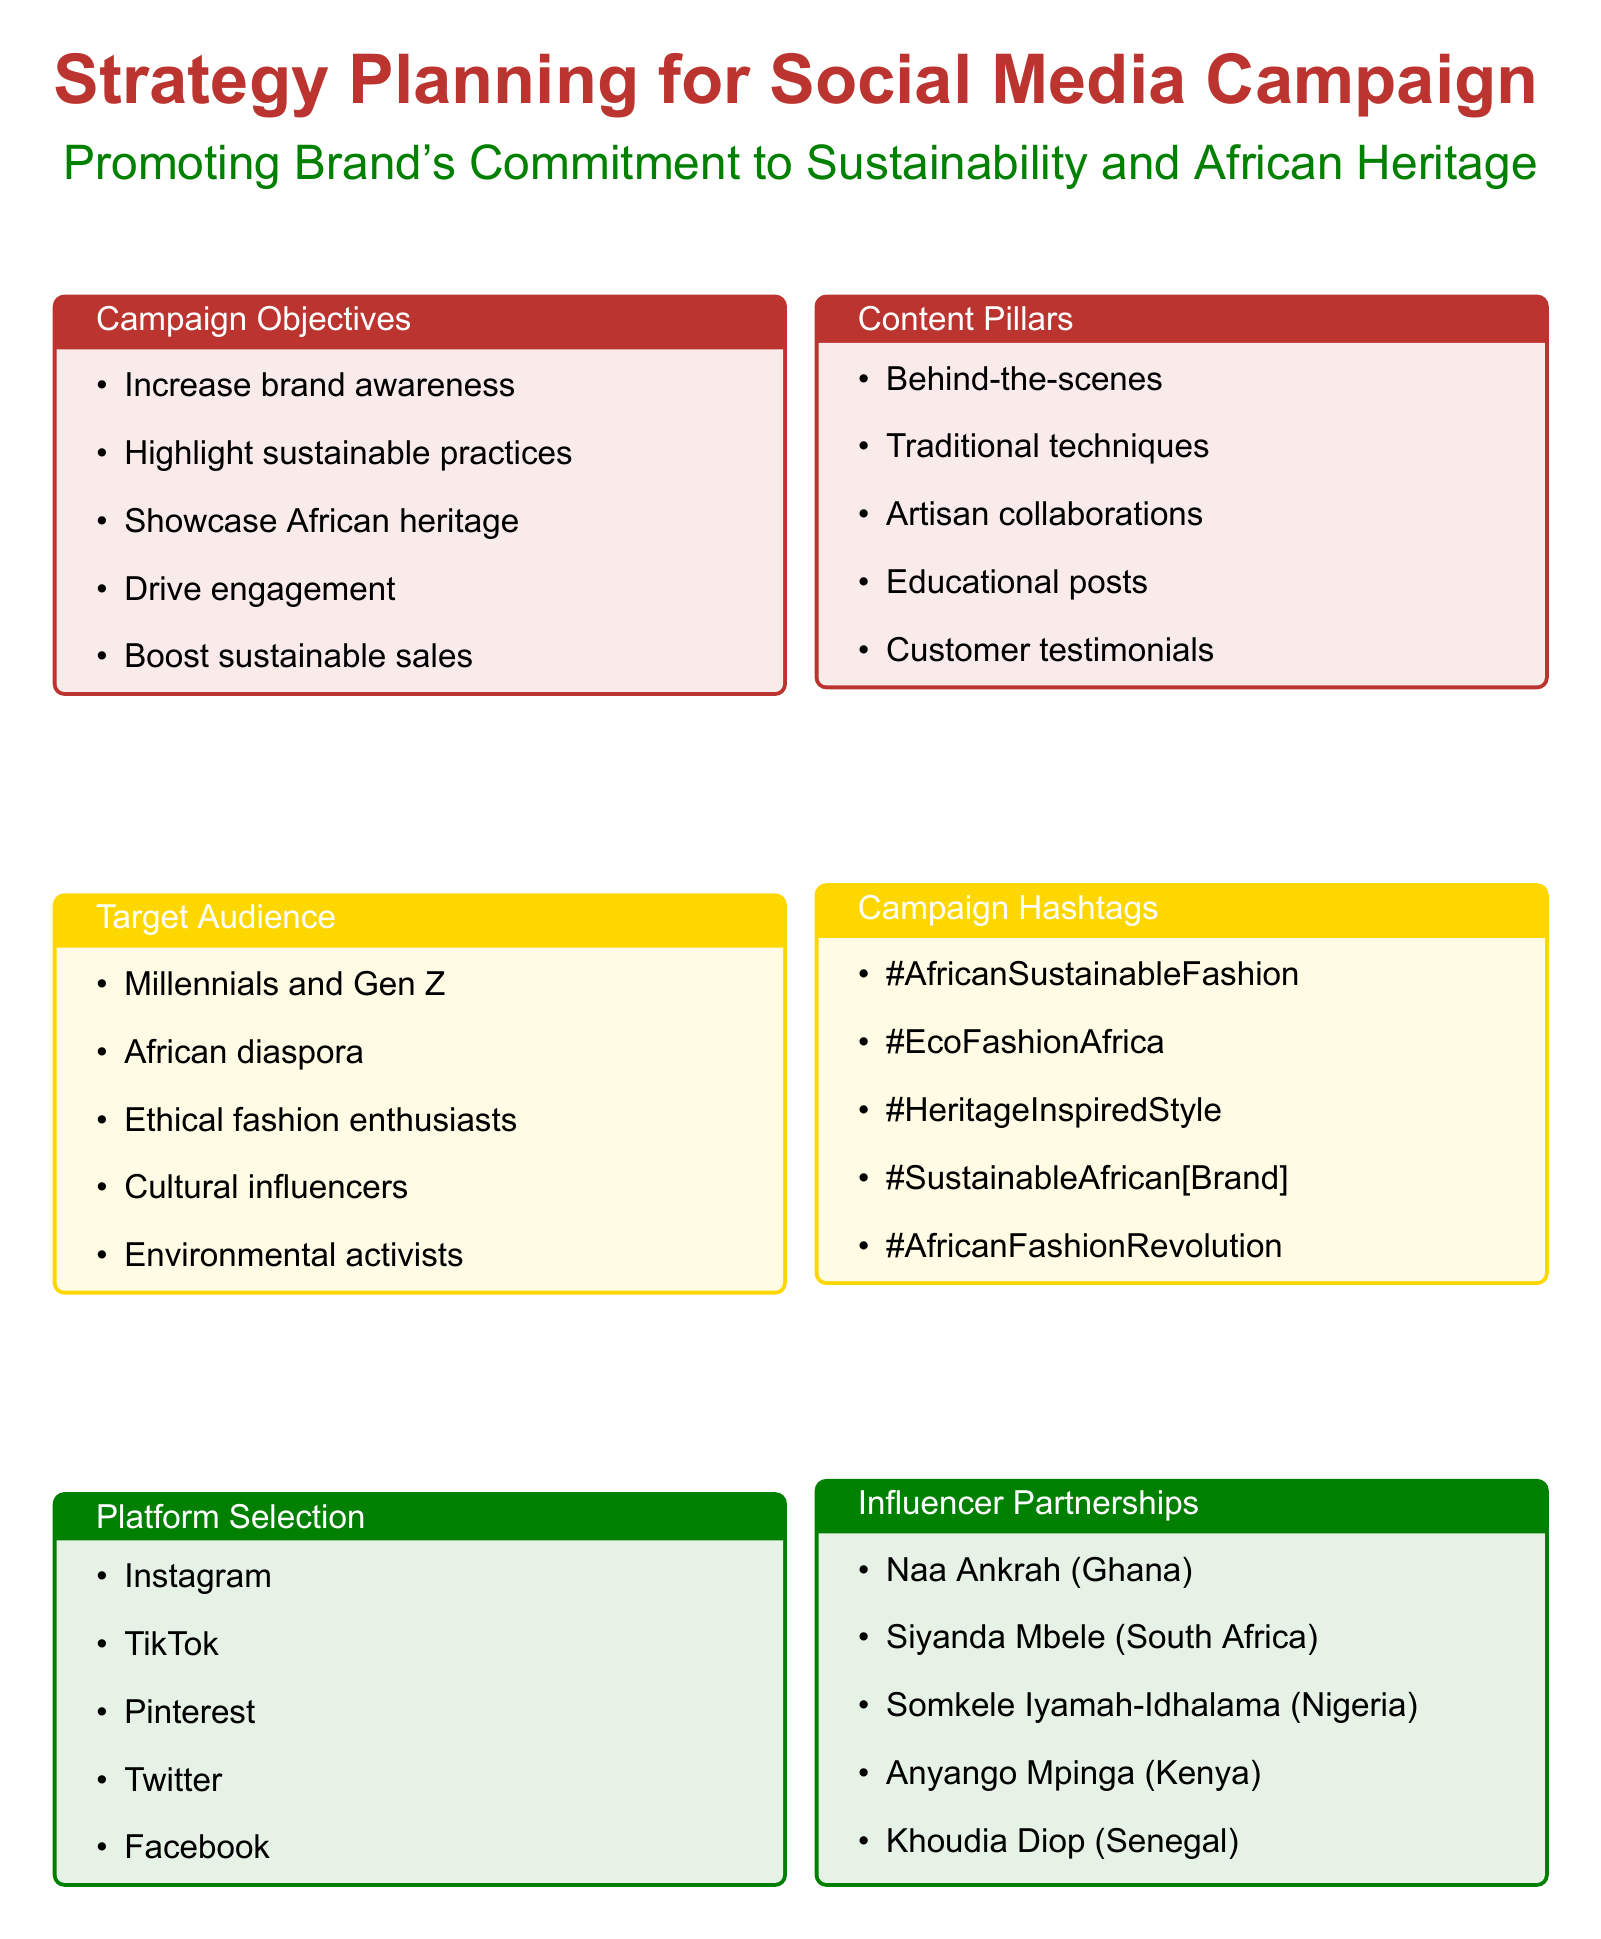What are the campaign objectives? The document lists several objectives for the campaign, emphasizing brand awareness, sustainable practices, and engagement.
Answer: Increase brand awareness among eco-conscious consumers, Highlight sustainable practices in African fashion, Showcase the brand's commitment to preserving African heritage, Drive engagement and user-generated content, Boost sales of sustainable African-inspired fashion items Who is the target audience? The document provides a detailed description of various groups targeted by the campaign.
Answer: Millennials and Gen Z interested in sustainable fashion, African diaspora in major global cities, Ethical fashion enthusiasts, Cultural influencers and trendsetters, Environmental activists and sustainability advocates Which social media platforms are selected for the campaign? The document specifies the platforms chosen for the social media campaign.
Answer: Instagram, TikTok, Pinterest, Twitter, Facebook What types of content will be shared? The document outlines various content pillars that will guide the creation of posts in the campaign.
Answer: Behind-the-scenes of sustainable production processes, Showcasing traditional African textile techniques, Collaborations with local artisans and communities, Educational posts on sustainable materials, Customer testimonials and styling tips What are the campaign hashtags? The document lists specific hashtags to be used in the campaign to enhance visibility and engagement.
Answer: #AfricanSustainableFashion, #EcoFashionAfrica, #HeritageInspiredStyle, #SustainableAfrican[BrandName], #AfricanFashionRevolution Who are the influencers targeted for partnerships? The document lists several influencers intended for collaboration in promoting the brand's message.
Answer: Collaboration with Ghanaian sustainable fashion advocate Naa Ankrah, Partnership with South African eco-lifestyle blogger Siyanda Mbele, Engagement with Nigerian actress and environmentalist Somkele Iyamah-Idhalama, Co-creation with Kenyan sustainable design expert Anyango Mpinga, Feature on Senegalese model and activist Khoudia Diop's platform What are the metrics and KPIs for the campaign? The document outlines key performance indicators to measure the campaign's success.
Answer: Follower growth on Instagram and TikTok, Engagement rate, Hashtag usage and reach, Website traffic from social media channels, Conversion rate for sustainable product lines What is the focus of sustainability storytelling? The document highlights specific areas that will be emphasized through storytelling related to sustainability.
Answer: Spotlight on eco-friendly dyes from African plants, Water conservation efforts in production processes, Partnerships with local recycling initiatives, Carbon footprint reduction strategies, Fair wage practices and community impact stories 